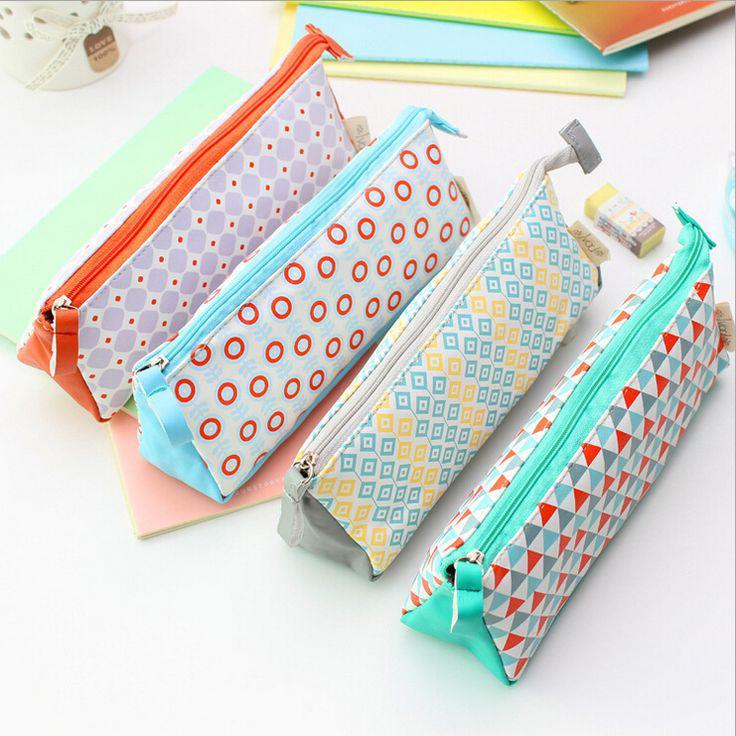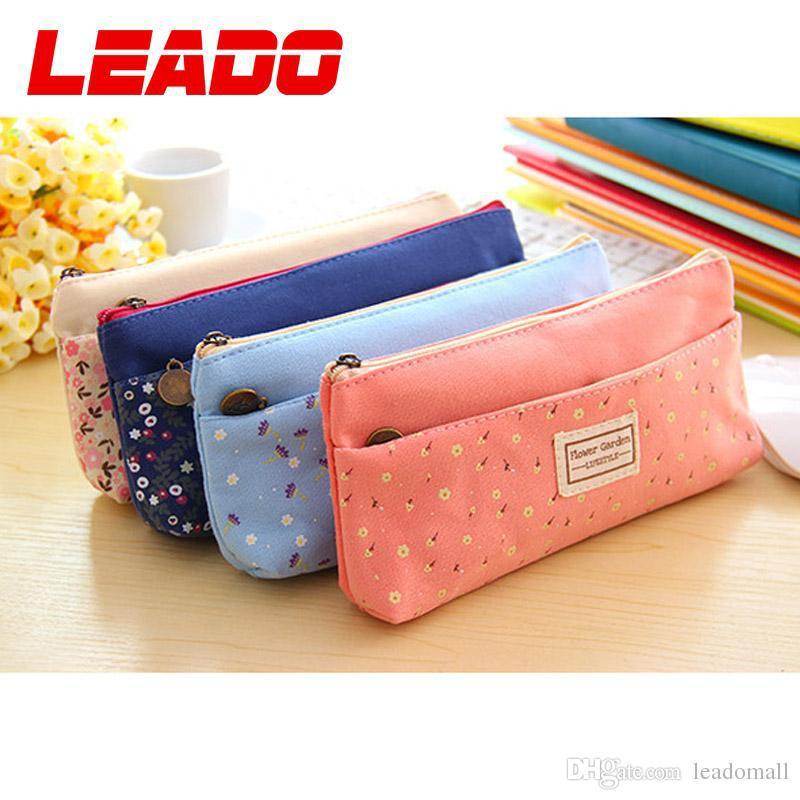The first image is the image on the left, the second image is the image on the right. Examine the images to the left and right. Is the description "The left image shows only a single pink case." accurate? Answer yes or no. No. 